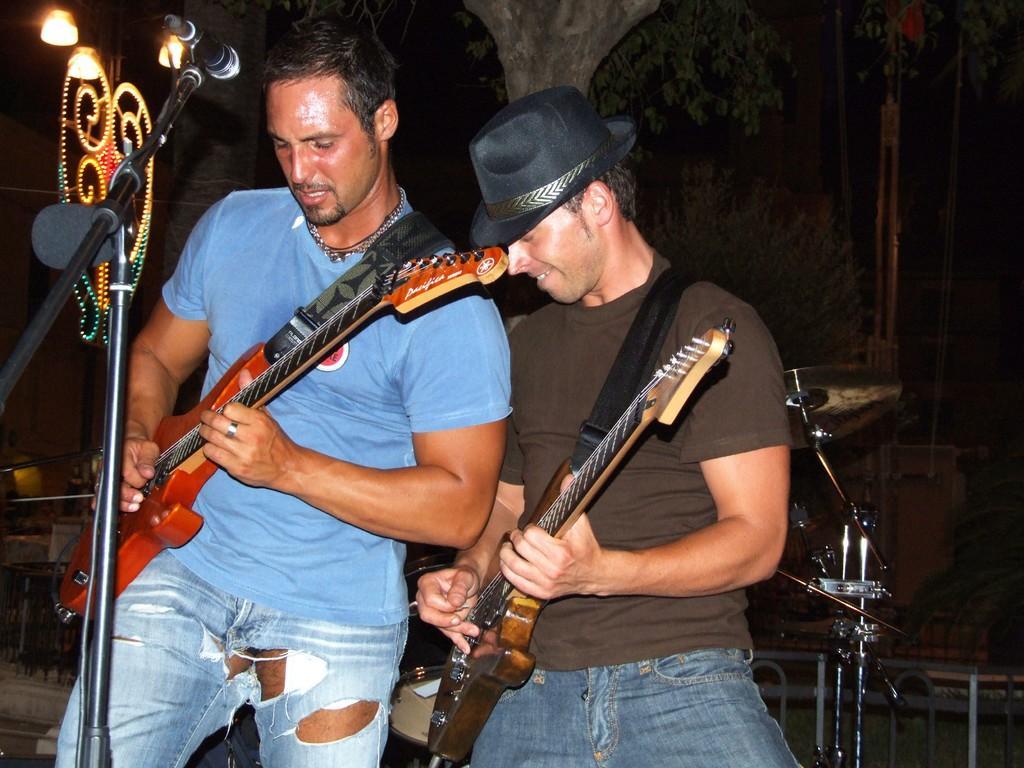Please provide a concise description of this image. In this image there are two persons there are two persons. In the middle of the image a man is standing, holding a guitar in his hand and playing the music. He is wearing a hat. In the left side of the image a man is standing holding a guitar in his hand and there is a mic. In the background there is a tree and there are few lights. 